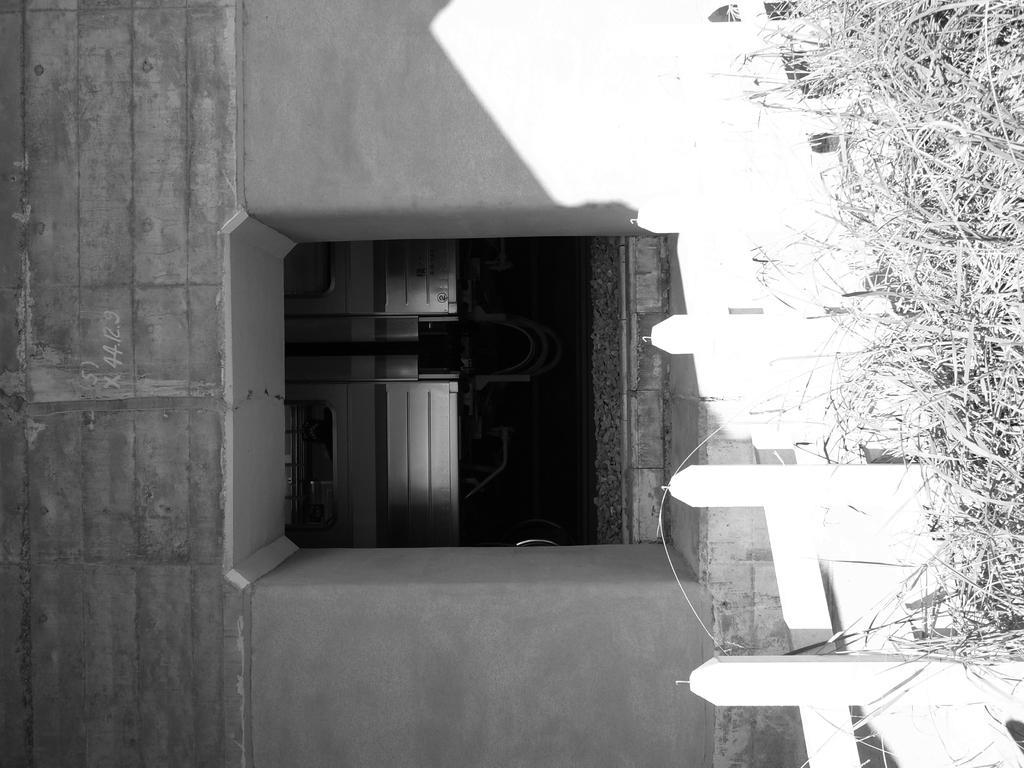How would you summarize this image in a sentence or two? In this picture, it seems like a boundary in the foreground and a building structure in the background. 